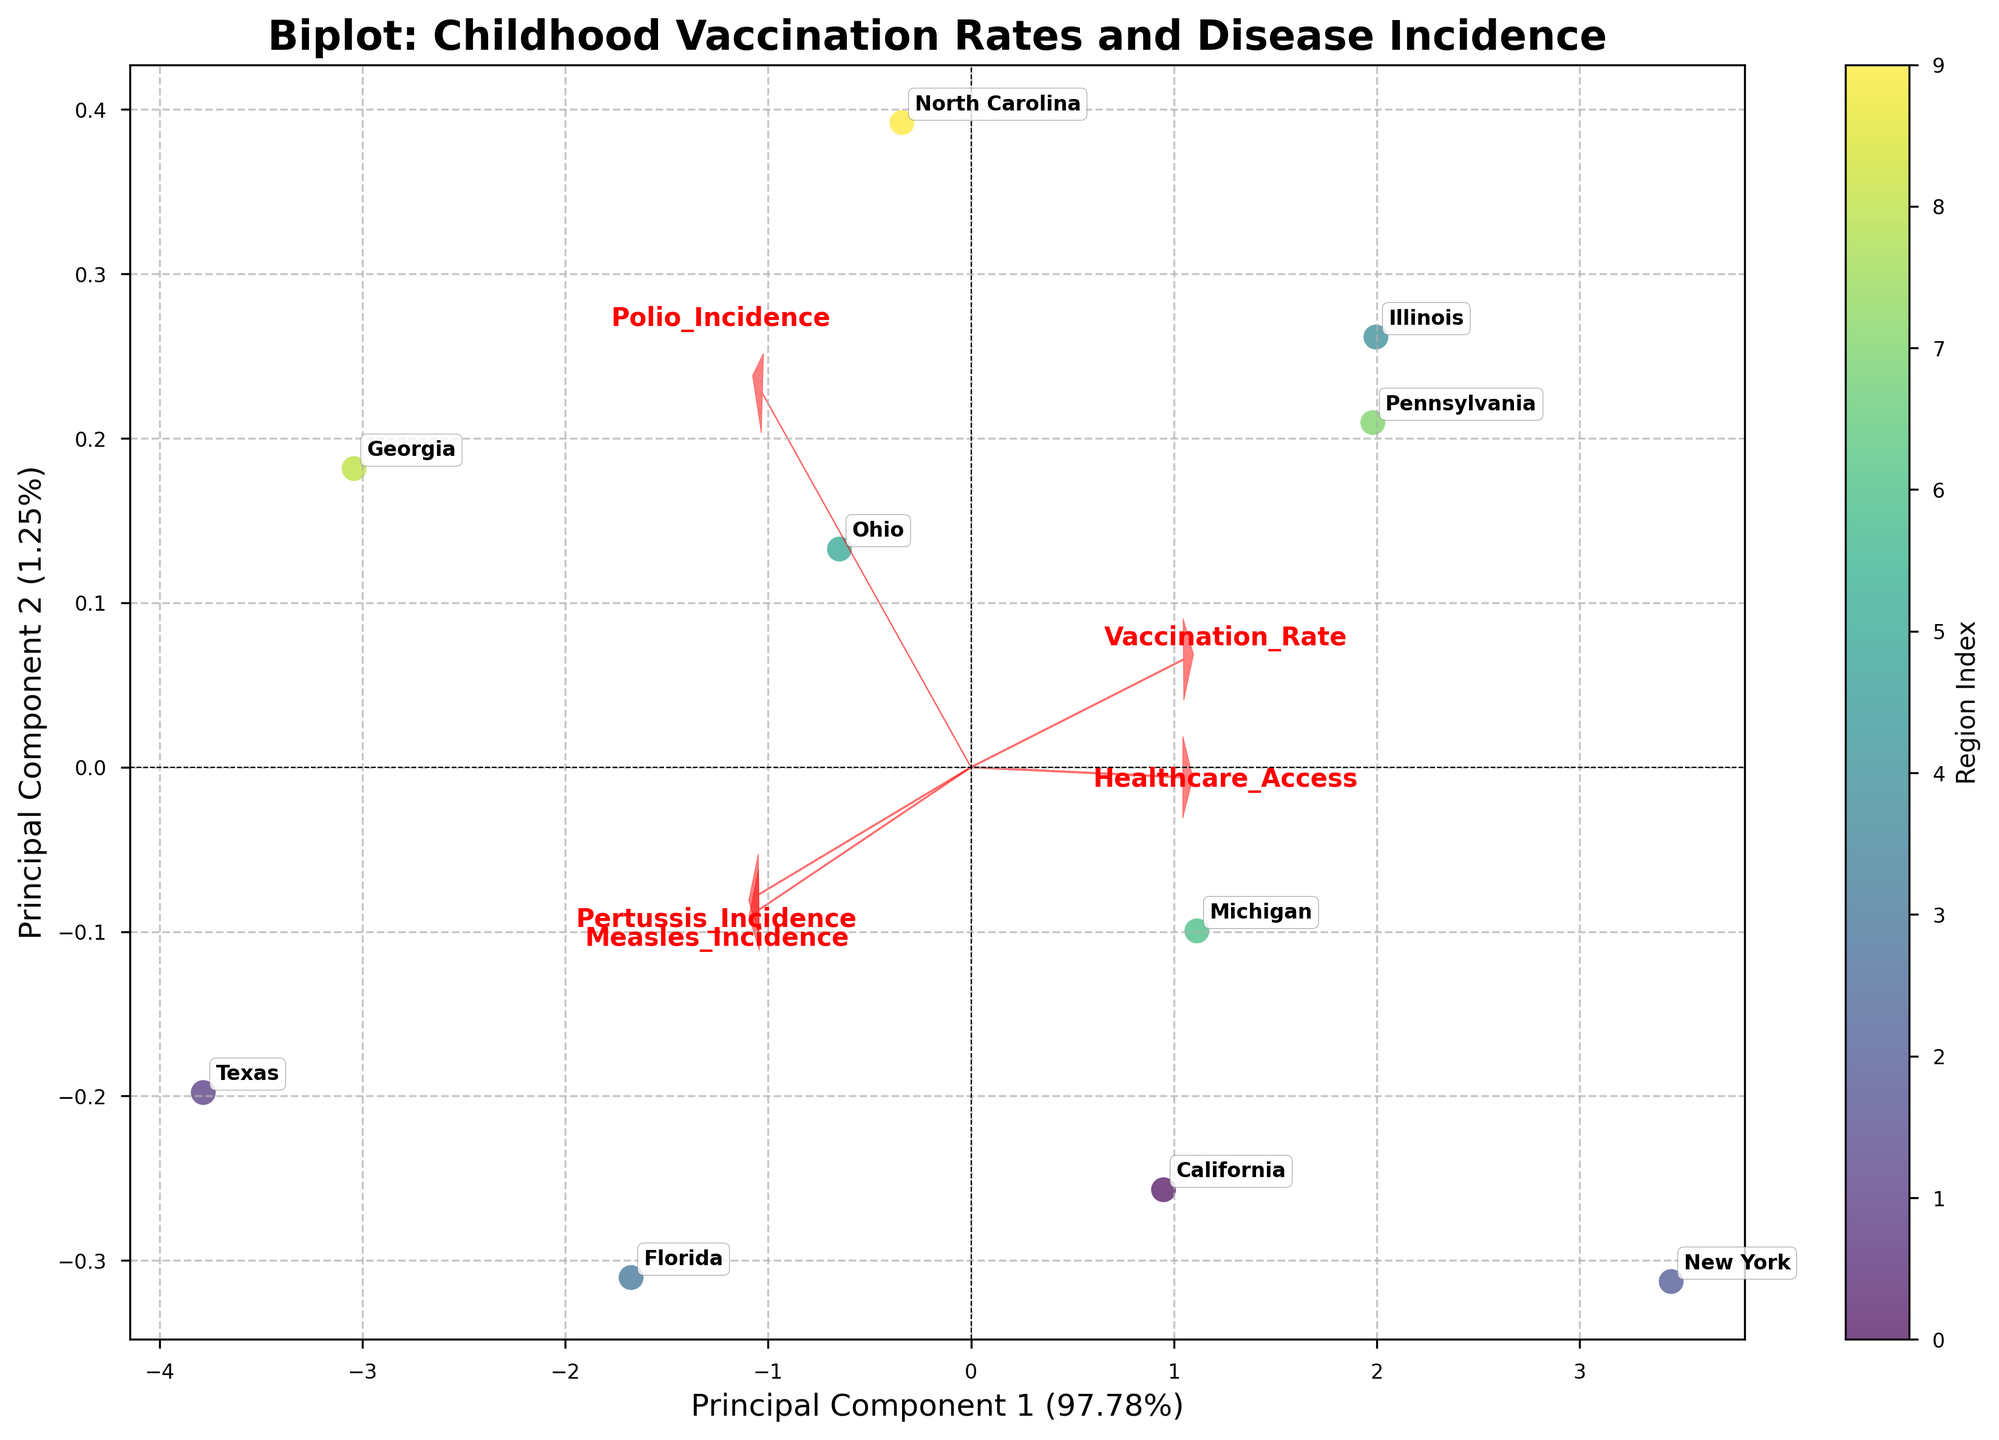What is the title of the biplot? The title of the biplot is displayed at the top of the figure, providing an overview of the data visualization.
Answer: Biplot: Childhood Vaccination Rates and Disease Incidence How many regions are displayed in the biplot? Count the number of unique region labels annotated in the plot.
Answer: 10 Which principal component explains more variance, PC1 or PC2? The x-axis label (PC1) and y-axis label (PC2) display the explained variance percentages. Compare these two values.
Answer: PC1 Which feature has the largest positive loading on PC1? Identify the feature arrow pointing most positively along the x-axis direction in the biplot.
Answer: Healthcare_Access Which region has the highest score on PC1? Look for the region annotated at the far right of the biplot along the x-axis (PC1).
Answer: New York Compare the Measles_Incidence and Polio_Incidence in terms of their loadings. Which has a stronger positive loading? Observe the lengths and directions of the arrows representing Measles_Incidence and Polio_Incidence and compare their x-axis components.
Answer: Measles_Incidence Which region appears closest to the origin in the biplot? Find the region label positioned nearest to the (0,0) coordinates in the figure.
Answer: North Carolina Which two features are most strongly positively correlated as depicted in the biplot? Look for two feature arrows pointing in nearly the same direction with similar magnitudes.
Answer: Vaccination_Rate and Healthcare_Access Which region has the highest incidence of Pertussis based on its score in the biplot? Identify the region positioned furthest along the direction of the Pertussis_Incidence arrow.
Answer: Texas Explain the relationship between Vaccination_Rate and Pertussis_Incidence observed in the biplot. Examine the angles between the arrows representing these features; arrows pointing in nearly opposite directions indicate a negative correlation.
Answer: Negative relationship 